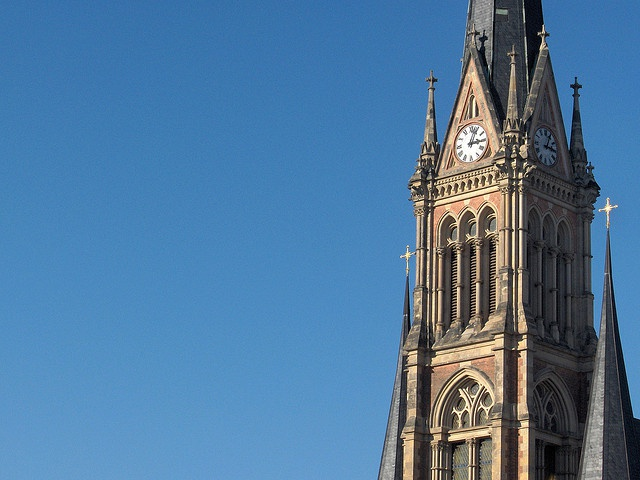Describe the objects in this image and their specific colors. I can see clock in gray, white, darkgray, and tan tones and clock in gray, blue, and black tones in this image. 